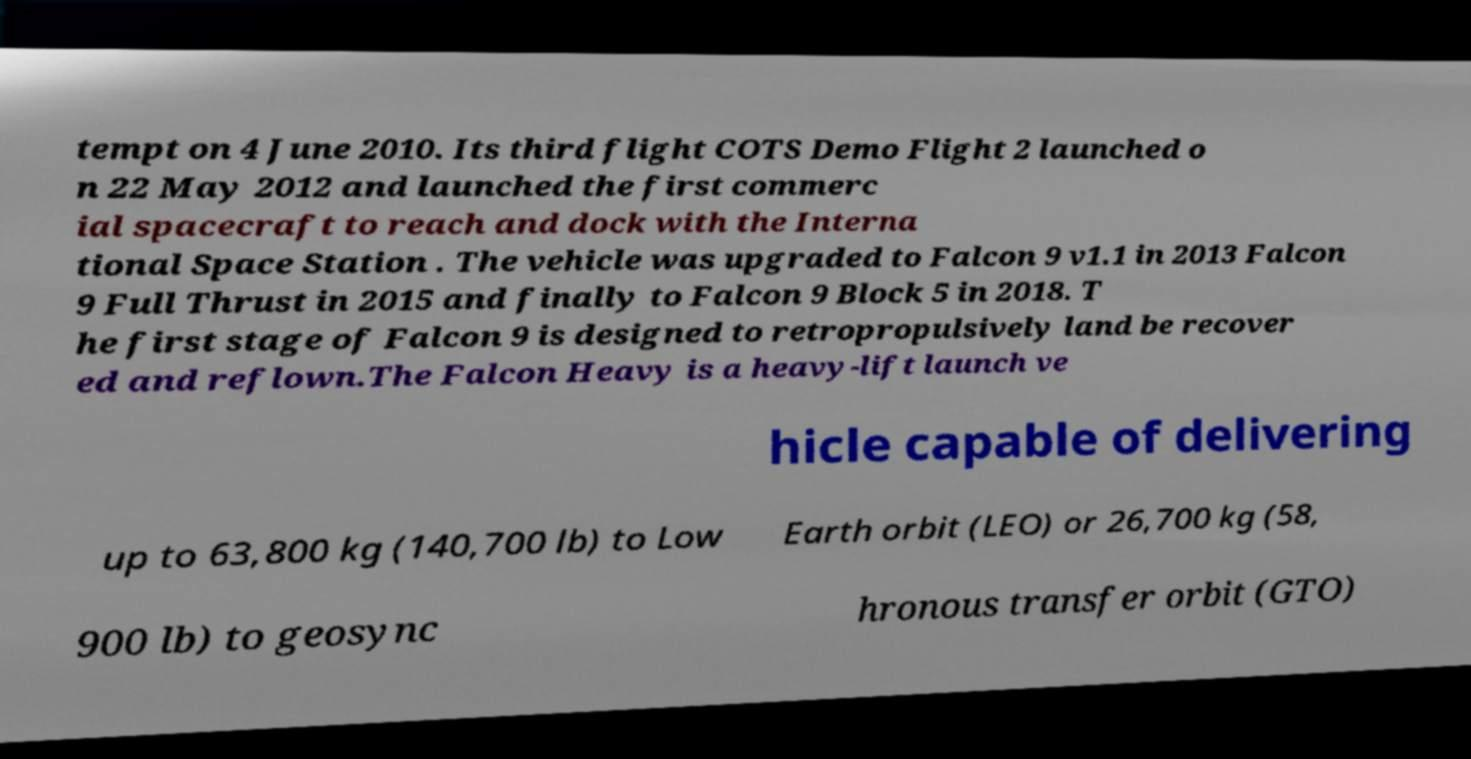There's text embedded in this image that I need extracted. Can you transcribe it verbatim? tempt on 4 June 2010. Its third flight COTS Demo Flight 2 launched o n 22 May 2012 and launched the first commerc ial spacecraft to reach and dock with the Interna tional Space Station . The vehicle was upgraded to Falcon 9 v1.1 in 2013 Falcon 9 Full Thrust in 2015 and finally to Falcon 9 Block 5 in 2018. T he first stage of Falcon 9 is designed to retropropulsively land be recover ed and reflown.The Falcon Heavy is a heavy-lift launch ve hicle capable of delivering up to 63,800 kg (140,700 lb) to Low Earth orbit (LEO) or 26,700 kg (58, 900 lb) to geosync hronous transfer orbit (GTO) 